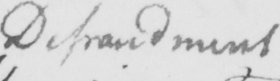What is written in this line of handwriting? Defraudment 